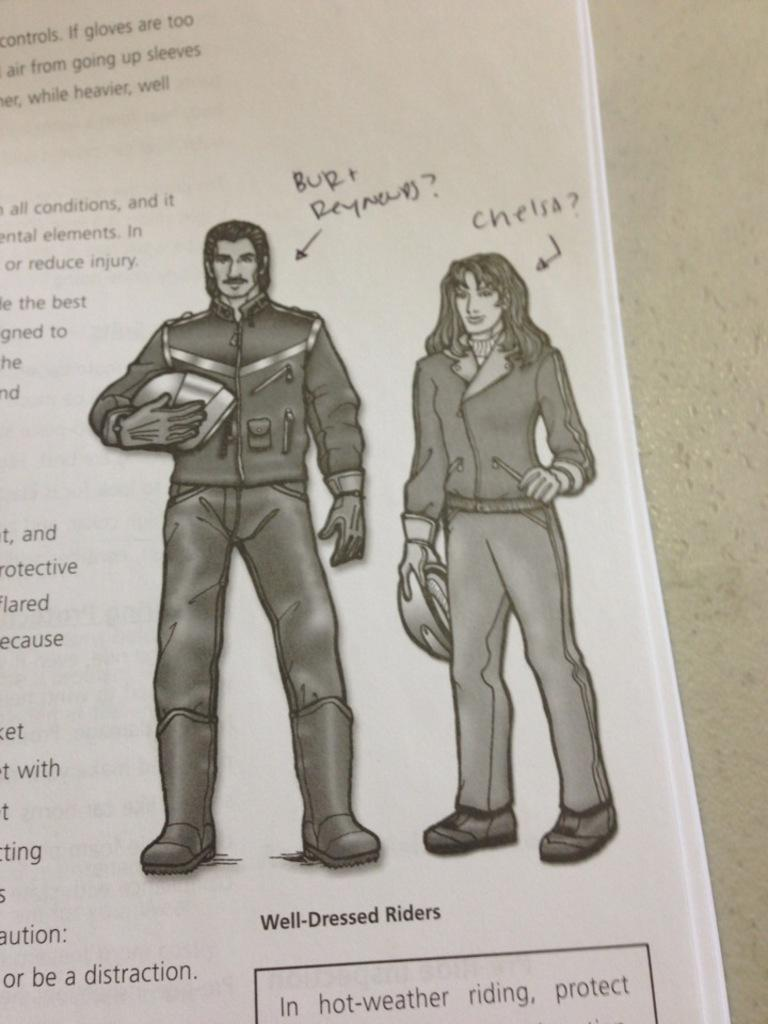What is present in the image that contains information or visuals? There is a paper in the image. What type of content is on the paper? The paper contains images of a person. Is there any text on the paper? Yes, there is text on the side of the paper. What type of snakes can be seen slithering on the paper in the image? There are no snakes present in the image; the paper contains images of a person and text. 